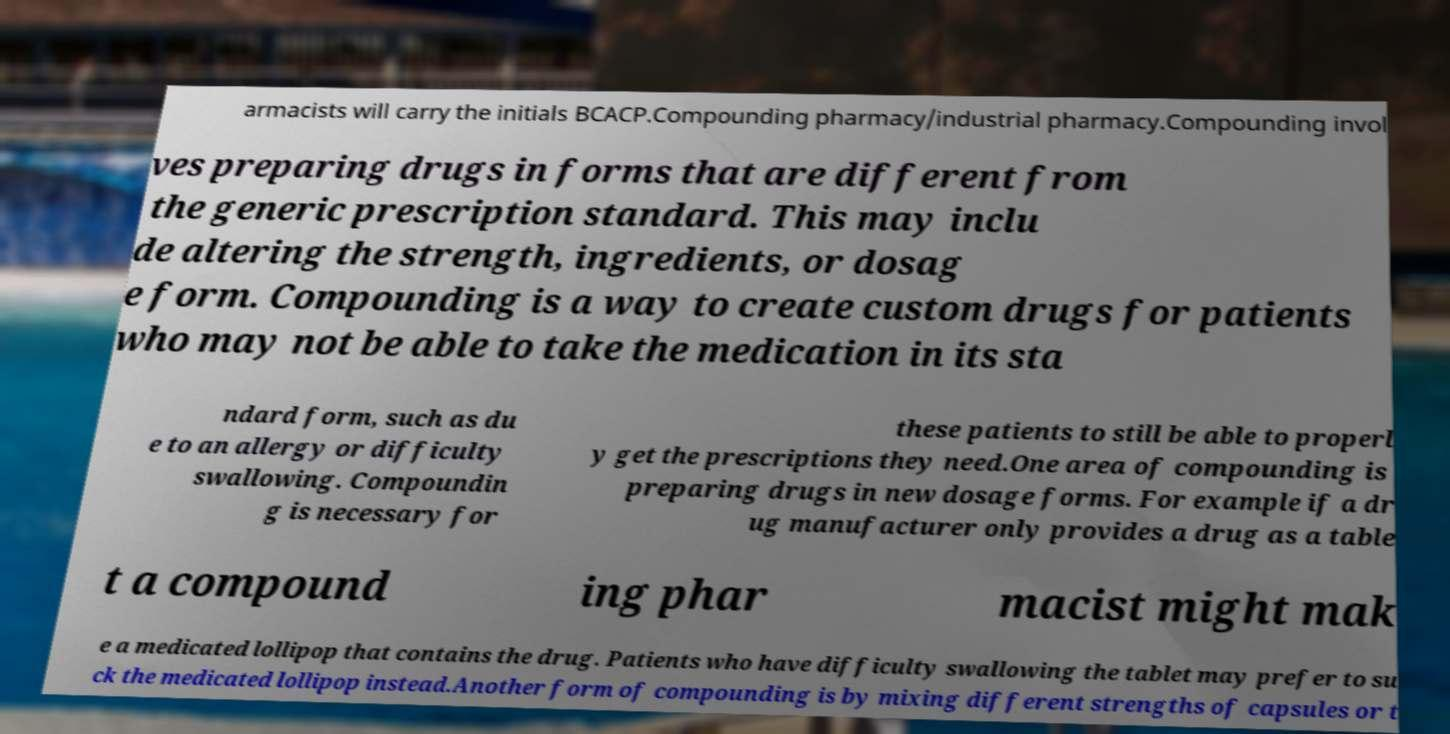Can you accurately transcribe the text from the provided image for me? armacists will carry the initials BCACP.Compounding pharmacy/industrial pharmacy.Compounding invol ves preparing drugs in forms that are different from the generic prescription standard. This may inclu de altering the strength, ingredients, or dosag e form. Compounding is a way to create custom drugs for patients who may not be able to take the medication in its sta ndard form, such as du e to an allergy or difficulty swallowing. Compoundin g is necessary for these patients to still be able to properl y get the prescriptions they need.One area of compounding is preparing drugs in new dosage forms. For example if a dr ug manufacturer only provides a drug as a table t a compound ing phar macist might mak e a medicated lollipop that contains the drug. Patients who have difficulty swallowing the tablet may prefer to su ck the medicated lollipop instead.Another form of compounding is by mixing different strengths of capsules or t 